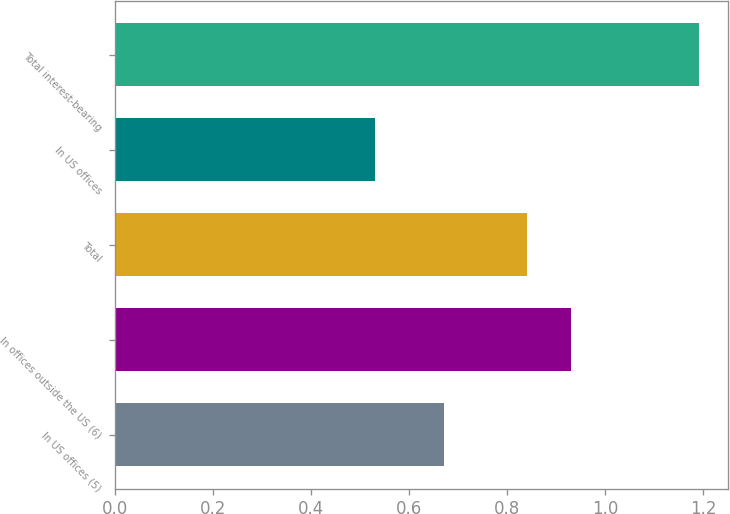Convert chart. <chart><loc_0><loc_0><loc_500><loc_500><bar_chart><fcel>In US offices (5)<fcel>In offices outside the US (6)<fcel>Total<fcel>In US offices<fcel>Total interest-bearing<nl><fcel>0.67<fcel>0.93<fcel>0.84<fcel>0.53<fcel>1.19<nl></chart> 